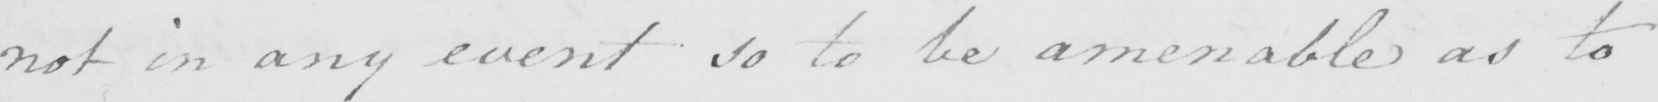Can you read and transcribe this handwriting? not in any event so to be amenable as to 